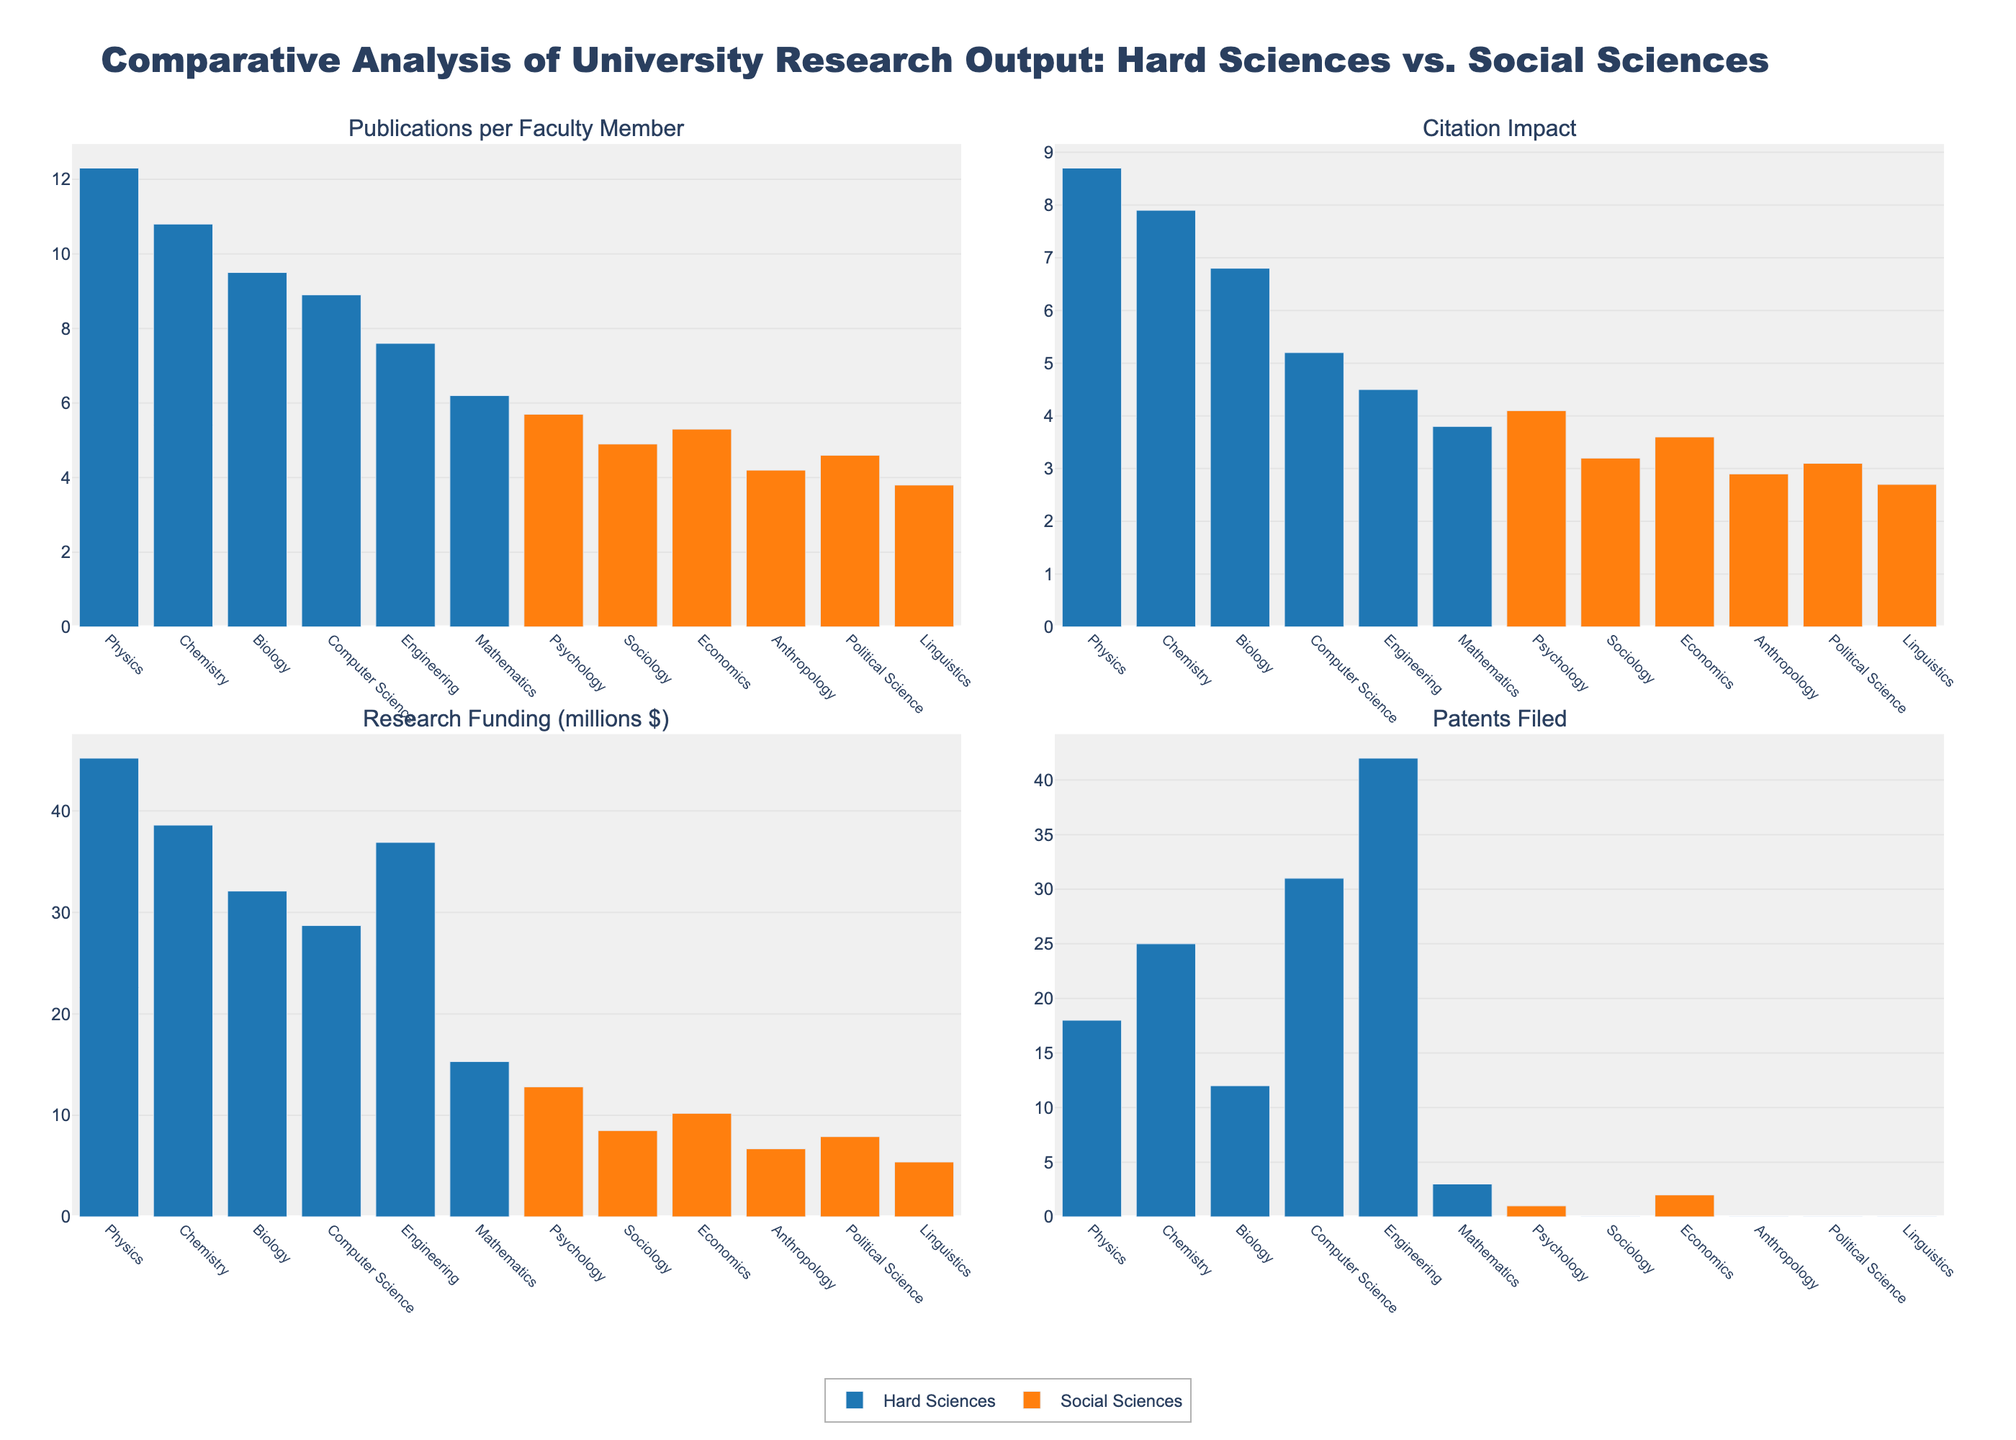What field has the highest number of patents filed in the hard sciences and what is that number? Look at the sub-plot titled "Patents Filed" and find the highest bar among the fields under "Hard Sciences". The highest bar corresponds to Engineering with 42 patents filed.
Answer: Engineering, 42 Which social science field has the highest citation impact? Refer to the "Citation Impact" subplot and identify the highest bar in the social sciences. Psychology has the highest citation impact in social sciences, which is 4.1.
Answer: Psychology, 4.1 How much more research funding do Physics departments receive compared to Sociology departments? Look at the "Research Funding (millions $)" subplot and locate the bars for Physics and Sociology. Physics receives 45.2 million dollars while Sociology receives 8.5 million dollars. Subtract 8.5 from 45.2 to get 36.7 million dollars.
Answer: 36.7 million dollars Which hard science and social science fields have the lowest number of publications per faculty member, and what are these numbers? In the "Publications per Faculty Member" subplot, identify the fields with the shortest bars in both hard sciences and social sciences. Mathematics has the lowest number in hard sciences with 6.2, and Linguistics has the lowest number in social sciences with 3.8.
Answer: Mathematics, 6.2; Linguistics, 3.8 Compare the number of patents filed between Computer Science and Chemistry. Which field has more, and by how much? Look at the "Patents Filed" subplot and find the corresponding bars for Computer Science and Chemistry. Computer Science has 31 patents filed and Chemistry has 25. Subtract 25 from 31 to find the difference.
Answer: Computer Science, by 6 What is the average number of publications per faculty member across all fields? Sum up the values of "Publications per Faculty Member" for all fields and divide by the total number of fields. The sum is 12.3+10.8+9.5+8.9+7.6+6.2+5.7+4.9+5.3+4.2+4.6+3.8 = 83.8. There are 12 fields, so the average is 83.8/12.
Answer: 6.98 Which field in the hard sciences has the lowest citation impact, and how does it compare to the field with the highest citation impact in the social sciences? In the "Citation Impact" subplot, find the field with the lowest bar in hard sciences (Mathematics with 3.8) and the highest bar in social sciences (Psychology with 4.1). Compare 3.8 and 4.1.
Answer: Mathematics, 3.8; Psychology, 4.1. Mathematics is lower by 0.3 Are there any fields in the social sciences that have filed patents? If so, which ones and how many? Check the "Patents Filed" subplot and look for any non-zero bars in the social sciences. Economics has filed 2 patents; other social sciences have filed none.
Answer: Economics, 2 What is the total research funding received by all fields in the hard sciences? Sum up the "Research Funding (millions $)" for all hard science fields. The total is 45.2 + 38.6 + 32.1 + 28.7 + 36.9 + 15.3 = 196.8 million dollars.
Answer: 196.8 million dollars 